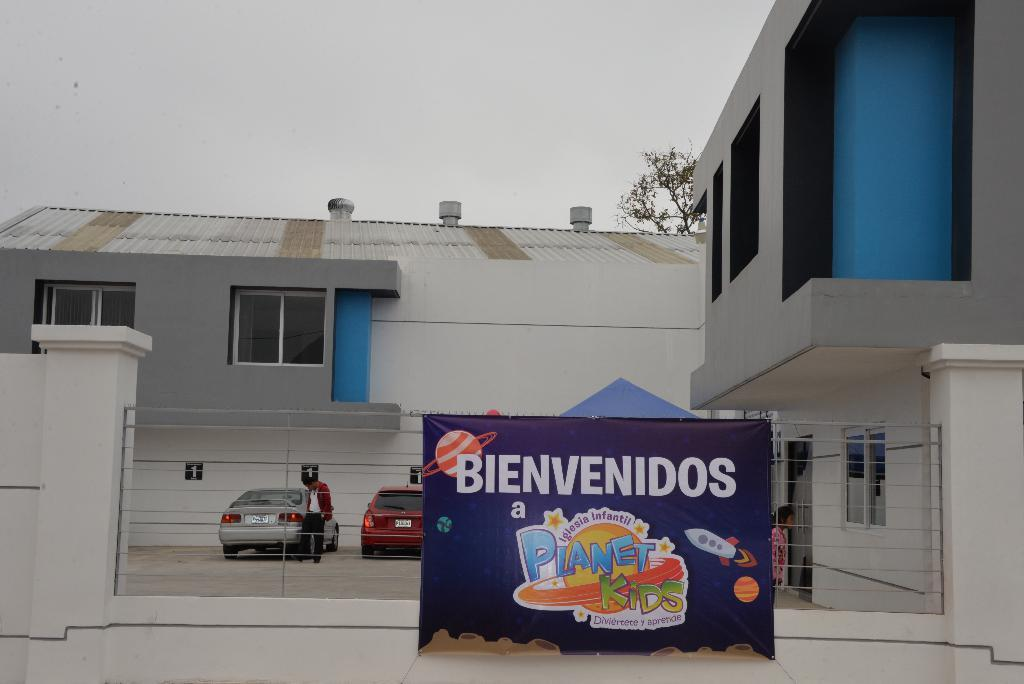What is the main subject in the image? There is a flex in the image. What can be seen behind the flex? There are cars parked behind the flex. Where are the cars located? The cars are in a parking lot. What is visible in the background of the image? There is a building and the sky in the background of the image. What type of cork can be seen on the sidewalk in the image? There is no cork or sidewalk present in the image; it features a flex, parked cars, a building, and the sky. 